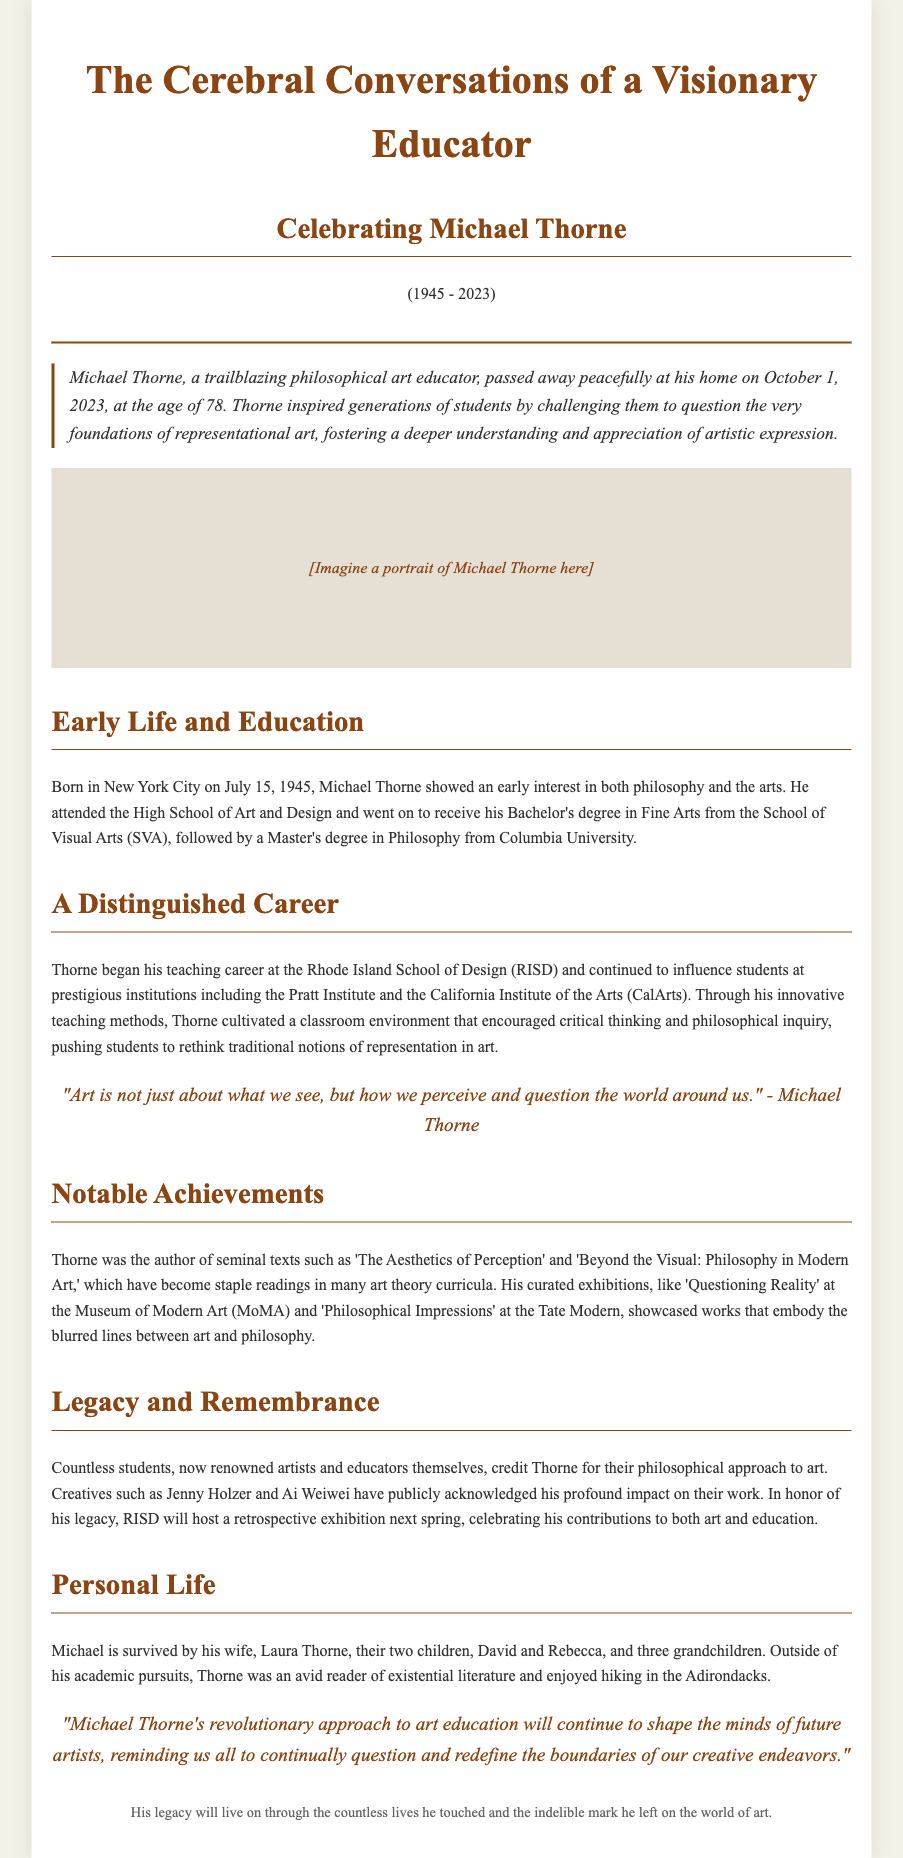What is the name of the educator being celebrated? The document is an obituary celebrating a specific individual, Michael Thorne, highlighting his contributions and impact.
Answer: Michael Thorne When did Michael Thorne pass away? The document specifies the date of Thorne's passing, which is a critical piece of information in an obituary.
Answer: October 1, 2023 What degree did Michael Thorne earn from Columbia University? The educational background of the subject is provided, including degrees obtained from notable institutions.
Answer: Master's degree in Philosophy Which institutions did Michael Thorne teach at? The document lists the prestigious institutions where Thorne taught, showcasing his career and influence.
Answer: Rhode Island School of Design, Pratt Institute, California Institute of the Arts What is the title of one of Michael Thorne's seminal texts? The document mentions Thorne's notable achievements, including his written works that have impacted the field of art education.
Answer: The Aesthetics of Perception What impact did Michael Thorne have on his students? The document discusses how his teaching influenced countless students and mentions specific renowned artists crediting their philosophical approach to art to him.
Answer: Inspired generations to question What type of event will RISD host in honor of Michael Thorne's legacy? The document describes a specific event that will celebrate Thorne's contributions to art and education posthumously.
Answer: Retrospective exhibition Who are the surviving family members mentioned in the obituary? The personal life section provides names of Thorne's family members, which is a typical inclusion in obituaries.
Answer: Laura Thorne, David, Rebecca Which artistic style did Michael Thorne challenge students to rethink? The document emphasizes the specific area of art that Thorne focused on during his teaching, relevant to his philosophical approach.
Answer: Representational art 